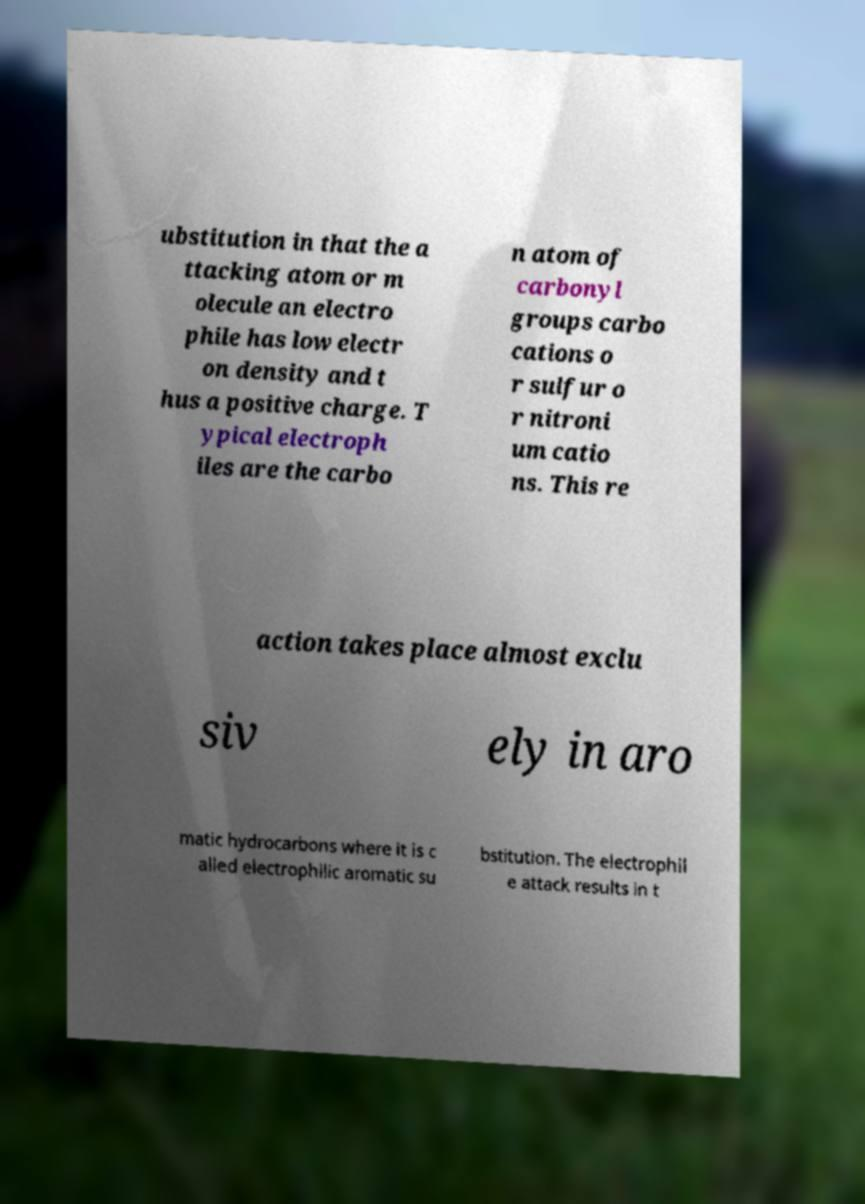Please identify and transcribe the text found in this image. ubstitution in that the a ttacking atom or m olecule an electro phile has low electr on density and t hus a positive charge. T ypical electroph iles are the carbo n atom of carbonyl groups carbo cations o r sulfur o r nitroni um catio ns. This re action takes place almost exclu siv ely in aro matic hydrocarbons where it is c alled electrophilic aromatic su bstitution. The electrophil e attack results in t 